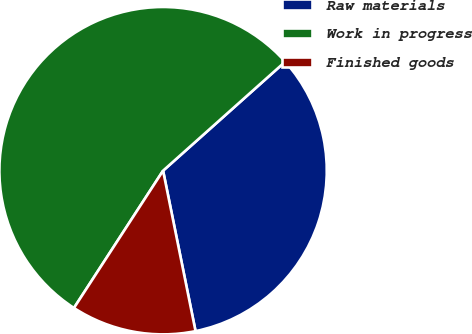<chart> <loc_0><loc_0><loc_500><loc_500><pie_chart><fcel>Raw materials<fcel>Work in progress<fcel>Finished goods<nl><fcel>33.42%<fcel>54.24%<fcel>12.34%<nl></chart> 